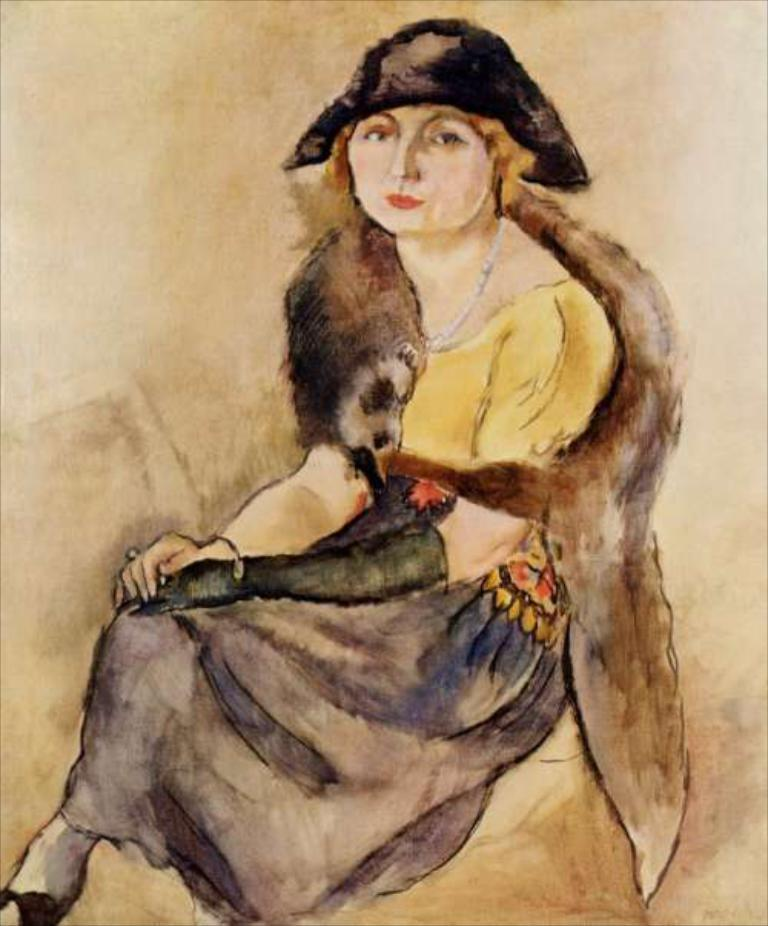What is the main subject of the image? There is a painting in the image. What is depicted in the painting? The painting depicts a person. What is the person in the painting doing? The person in the painting appears to be sitting and posing for a photo. What type of arithmetic problem is the person in the painting solving? There is no arithmetic problem present in the image; it features a painting of a person sitting and posing for a photo. What kind of rod can be seen in the painting? There is no rod present in the painting; it depicts a person sitting and posing for a photo. 